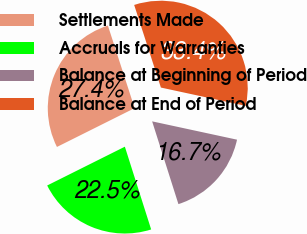Convert chart. <chart><loc_0><loc_0><loc_500><loc_500><pie_chart><fcel>Settlements Made<fcel>Accruals for Warranties<fcel>Balance at Beginning of Period<fcel>Balance at End of Period<nl><fcel>27.39%<fcel>22.52%<fcel>16.72%<fcel>33.36%<nl></chart> 